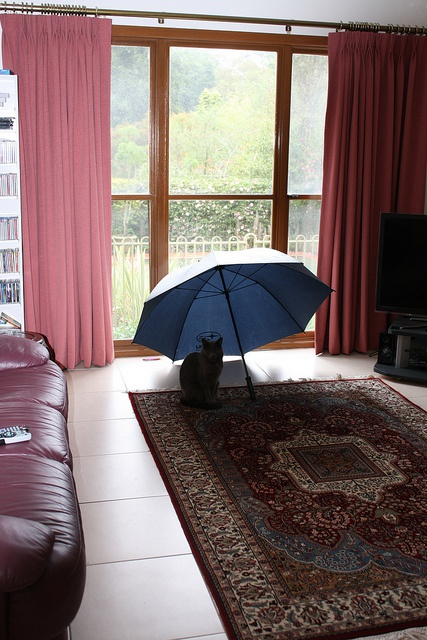Describe the objects in this image and their specific colors. I can see couch in lightgray, black, purple, darkgray, and gray tones, umbrella in lightgray, navy, black, darkblue, and white tones, tv in lightgray, black, gray, and purple tones, cat in lightgray, black, and gray tones, and remote in lightgray, lavender, gray, black, and darkgray tones in this image. 